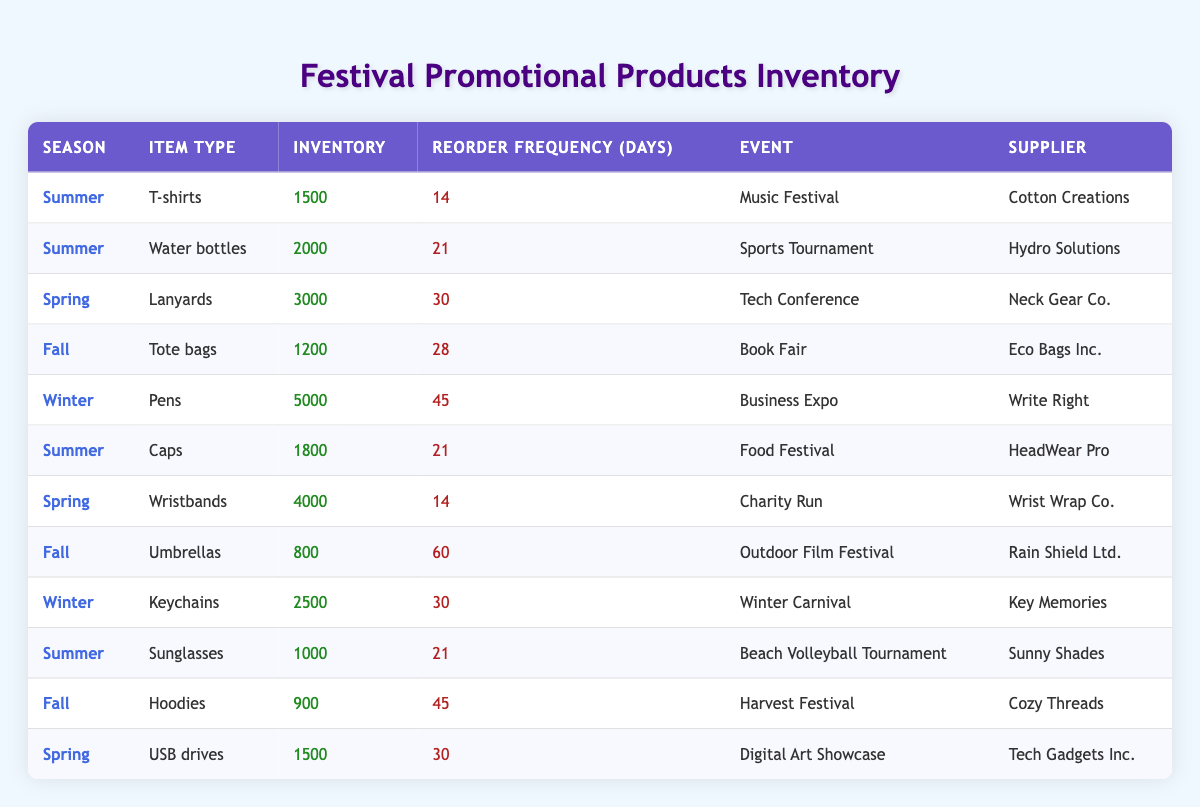What is the inventory count for T-shirts? The table shows the row for T-shirts under the Summer season. The inventory value listed in that row is 1500.
Answer: 1500 Which item type has the highest reorder frequency? To find the highest reorder frequency, we need to compare all the reorder frequency values in the table. The values are 14, 21, 30, 28, 45, 60, and 14. The highest value is 60, which corresponds to Umbrellas in the Fall season.
Answer: Umbrellas How many items are available during the Spring season? There are three items listed under the Spring season: Lanyards, Wristbands, and USB drives. So there are 3 items available for that season.
Answer: 3 What is the total inventory for Summer items? To find the total inventory for Summer items, we need to sum the inventory counts of T-shirts (1500), Water bottles (2000), Caps (1800), and Sunglasses (1000). The sum is 1500 + 2000 + 1800 + 1000 = 7300.
Answer: 7300 Is there an item with a reorder frequency of 45 days? By scanning the reorder frequency column, the value 45 appears twice: once for Pens and once for Hoodies. Therefore, there are items with a reorder frequency of 45 days.
Answer: Yes What is the average inventory for Fall items? There are three Fall items: Tote bags (1200), Umbrellas (800), and Hoodies (900). To calculate the average, first sum the inventories: 1200 + 800 + 900 = 2900. Then, divide by the number of items (3), yielding an average of 2900 / 3 = approximately 966.67.
Answer: 966.67 Which event corresponds to the item type "Wristbands"? The table shows Wristbands under the Spring season. The corresponding event listed is Charity Run.
Answer: Charity Run What season has the most items available? Upon reviewing the table, Summer has 4 items (T-shirts, Water bottles, Caps, Sunglasses), Spring has 3, Fall has 3, and Winter has 2. Therefore, Summer has the most items available.
Answer: Summer 